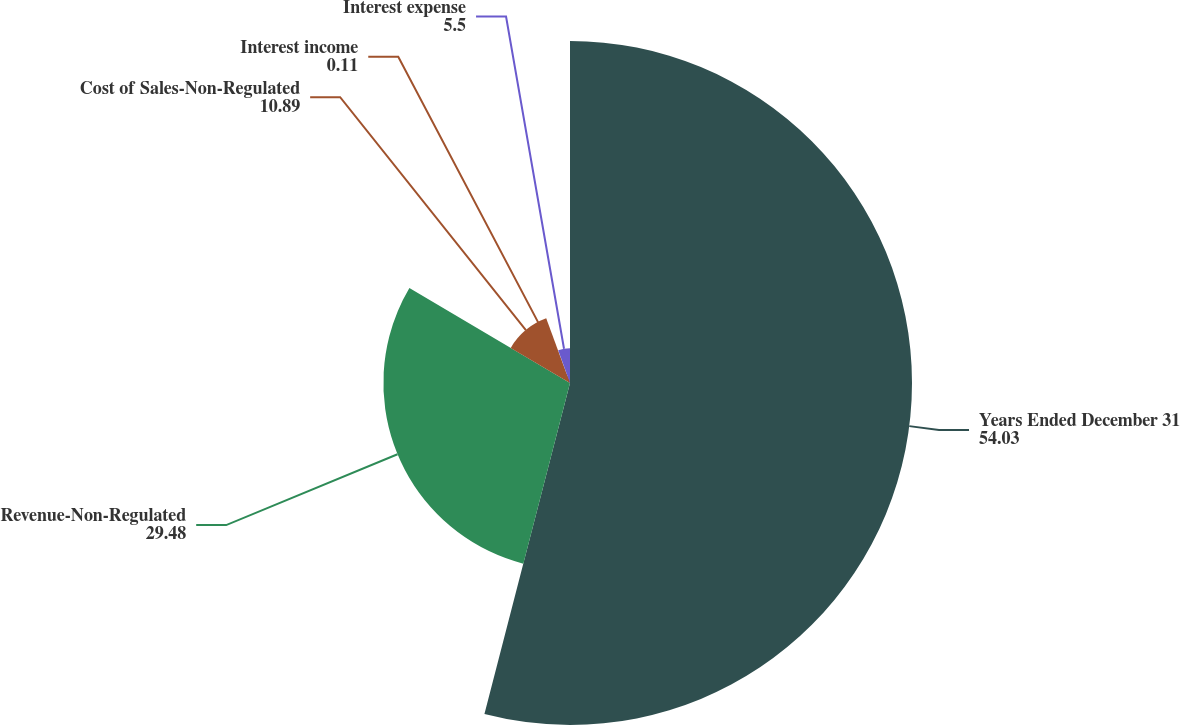<chart> <loc_0><loc_0><loc_500><loc_500><pie_chart><fcel>Years Ended December 31<fcel>Revenue-Non-Regulated<fcel>Cost of Sales-Non-Regulated<fcel>Interest income<fcel>Interest expense<nl><fcel>54.03%<fcel>29.48%<fcel>10.89%<fcel>0.11%<fcel>5.5%<nl></chart> 